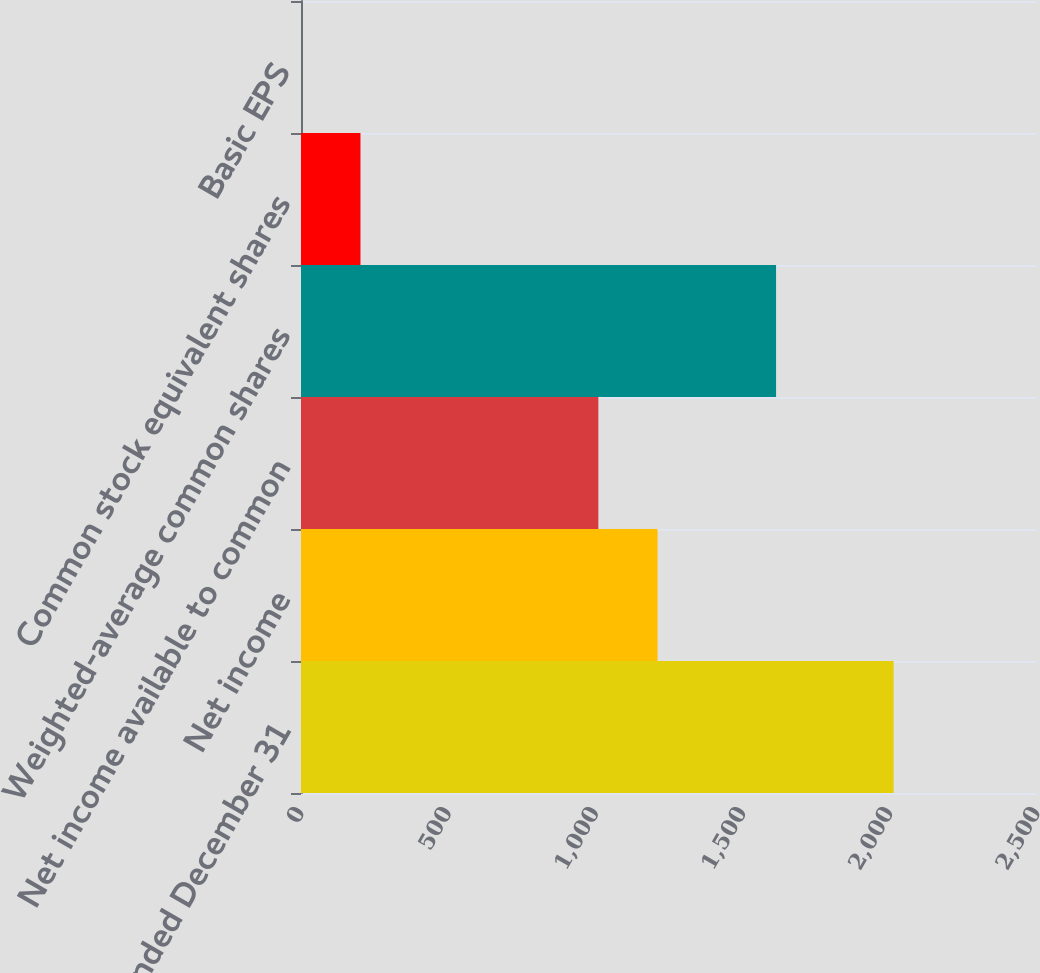Convert chart to OTSL. <chart><loc_0><loc_0><loc_500><loc_500><bar_chart><fcel>Year Ended December 31<fcel>Net income<fcel>Net income available to common<fcel>Weighted-average common shares<fcel>Common stock equivalent shares<fcel>Basic EPS<nl><fcel>2013<fcel>1211.22<fcel>1010<fcel>1613.66<fcel>202<fcel>0.78<nl></chart> 